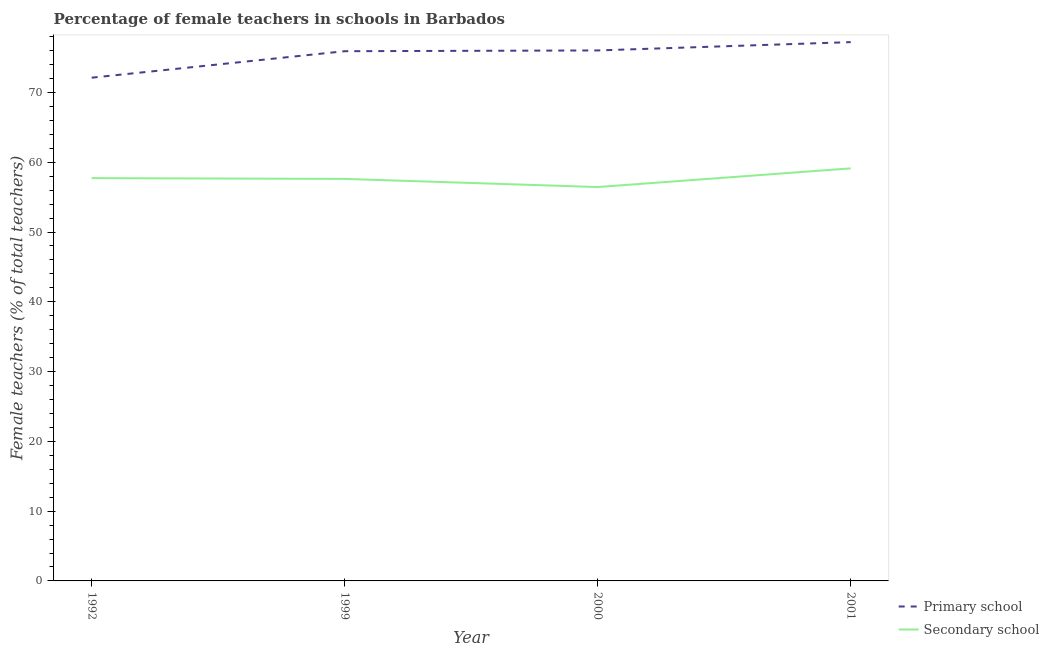How many different coloured lines are there?
Offer a terse response. 2. Does the line corresponding to percentage of female teachers in primary schools intersect with the line corresponding to percentage of female teachers in secondary schools?
Ensure brevity in your answer.  No. What is the percentage of female teachers in secondary schools in 1992?
Make the answer very short. 57.72. Across all years, what is the maximum percentage of female teachers in secondary schools?
Provide a succinct answer. 59.13. Across all years, what is the minimum percentage of female teachers in secondary schools?
Your response must be concise. 56.45. In which year was the percentage of female teachers in secondary schools maximum?
Offer a very short reply. 2001. What is the total percentage of female teachers in secondary schools in the graph?
Your response must be concise. 230.91. What is the difference between the percentage of female teachers in primary schools in 1992 and that in 2000?
Offer a very short reply. -3.9. What is the difference between the percentage of female teachers in secondary schools in 1999 and the percentage of female teachers in primary schools in 2000?
Ensure brevity in your answer.  -18.41. What is the average percentage of female teachers in secondary schools per year?
Your response must be concise. 57.73. In the year 2001, what is the difference between the percentage of female teachers in primary schools and percentage of female teachers in secondary schools?
Your answer should be compact. 18.09. In how many years, is the percentage of female teachers in secondary schools greater than 70 %?
Make the answer very short. 0. What is the ratio of the percentage of female teachers in primary schools in 2000 to that in 2001?
Your answer should be compact. 0.98. Is the difference between the percentage of female teachers in primary schools in 1992 and 1999 greater than the difference between the percentage of female teachers in secondary schools in 1992 and 1999?
Offer a terse response. No. What is the difference between the highest and the second highest percentage of female teachers in secondary schools?
Make the answer very short. 1.4. What is the difference between the highest and the lowest percentage of female teachers in primary schools?
Offer a very short reply. 5.1. Is the sum of the percentage of female teachers in secondary schools in 1992 and 2001 greater than the maximum percentage of female teachers in primary schools across all years?
Your answer should be very brief. Yes. How many lines are there?
Your answer should be very brief. 2. How many years are there in the graph?
Your response must be concise. 4. What is the difference between two consecutive major ticks on the Y-axis?
Keep it short and to the point. 10. Does the graph contain grids?
Keep it short and to the point. No. How many legend labels are there?
Ensure brevity in your answer.  2. What is the title of the graph?
Your response must be concise. Percentage of female teachers in schools in Barbados. What is the label or title of the X-axis?
Your response must be concise. Year. What is the label or title of the Y-axis?
Give a very brief answer. Female teachers (% of total teachers). What is the Female teachers (% of total teachers) of Primary school in 1992?
Provide a succinct answer. 72.12. What is the Female teachers (% of total teachers) of Secondary school in 1992?
Keep it short and to the point. 57.72. What is the Female teachers (% of total teachers) in Primary school in 1999?
Offer a very short reply. 75.91. What is the Female teachers (% of total teachers) of Secondary school in 1999?
Provide a short and direct response. 57.61. What is the Female teachers (% of total teachers) of Primary school in 2000?
Your answer should be compact. 76.02. What is the Female teachers (% of total teachers) of Secondary school in 2000?
Make the answer very short. 56.45. What is the Female teachers (% of total teachers) of Primary school in 2001?
Ensure brevity in your answer.  77.22. What is the Female teachers (% of total teachers) of Secondary school in 2001?
Make the answer very short. 59.13. Across all years, what is the maximum Female teachers (% of total teachers) of Primary school?
Ensure brevity in your answer.  77.22. Across all years, what is the maximum Female teachers (% of total teachers) in Secondary school?
Offer a terse response. 59.13. Across all years, what is the minimum Female teachers (% of total teachers) of Primary school?
Your response must be concise. 72.12. Across all years, what is the minimum Female teachers (% of total teachers) of Secondary school?
Keep it short and to the point. 56.45. What is the total Female teachers (% of total teachers) of Primary school in the graph?
Give a very brief answer. 301.27. What is the total Female teachers (% of total teachers) of Secondary school in the graph?
Your response must be concise. 230.91. What is the difference between the Female teachers (% of total teachers) in Primary school in 1992 and that in 1999?
Offer a very short reply. -3.8. What is the difference between the Female teachers (% of total teachers) of Secondary school in 1992 and that in 1999?
Give a very brief answer. 0.11. What is the difference between the Female teachers (% of total teachers) in Primary school in 1992 and that in 2000?
Ensure brevity in your answer.  -3.9. What is the difference between the Female teachers (% of total teachers) of Secondary school in 1992 and that in 2000?
Give a very brief answer. 1.28. What is the difference between the Female teachers (% of total teachers) of Primary school in 1992 and that in 2001?
Make the answer very short. -5.1. What is the difference between the Female teachers (% of total teachers) in Secondary school in 1992 and that in 2001?
Make the answer very short. -1.4. What is the difference between the Female teachers (% of total teachers) in Primary school in 1999 and that in 2000?
Offer a very short reply. -0.11. What is the difference between the Female teachers (% of total teachers) in Secondary school in 1999 and that in 2000?
Make the answer very short. 1.17. What is the difference between the Female teachers (% of total teachers) in Primary school in 1999 and that in 2001?
Make the answer very short. -1.3. What is the difference between the Female teachers (% of total teachers) of Secondary school in 1999 and that in 2001?
Offer a very short reply. -1.51. What is the difference between the Female teachers (% of total teachers) of Primary school in 2000 and that in 2001?
Offer a very short reply. -1.19. What is the difference between the Female teachers (% of total teachers) in Secondary school in 2000 and that in 2001?
Offer a terse response. -2.68. What is the difference between the Female teachers (% of total teachers) of Primary school in 1992 and the Female teachers (% of total teachers) of Secondary school in 1999?
Your answer should be very brief. 14.51. What is the difference between the Female teachers (% of total teachers) in Primary school in 1992 and the Female teachers (% of total teachers) in Secondary school in 2000?
Keep it short and to the point. 15.67. What is the difference between the Female teachers (% of total teachers) of Primary school in 1992 and the Female teachers (% of total teachers) of Secondary school in 2001?
Keep it short and to the point. 12.99. What is the difference between the Female teachers (% of total teachers) of Primary school in 1999 and the Female teachers (% of total teachers) of Secondary school in 2000?
Your response must be concise. 19.47. What is the difference between the Female teachers (% of total teachers) in Primary school in 1999 and the Female teachers (% of total teachers) in Secondary school in 2001?
Offer a terse response. 16.79. What is the difference between the Female teachers (% of total teachers) in Primary school in 2000 and the Female teachers (% of total teachers) in Secondary school in 2001?
Your answer should be very brief. 16.9. What is the average Female teachers (% of total teachers) in Primary school per year?
Give a very brief answer. 75.32. What is the average Female teachers (% of total teachers) of Secondary school per year?
Keep it short and to the point. 57.73. In the year 1992, what is the difference between the Female teachers (% of total teachers) of Primary school and Female teachers (% of total teachers) of Secondary school?
Ensure brevity in your answer.  14.39. In the year 1999, what is the difference between the Female teachers (% of total teachers) of Primary school and Female teachers (% of total teachers) of Secondary school?
Your response must be concise. 18.3. In the year 2000, what is the difference between the Female teachers (% of total teachers) of Primary school and Female teachers (% of total teachers) of Secondary school?
Make the answer very short. 19.58. In the year 2001, what is the difference between the Female teachers (% of total teachers) in Primary school and Female teachers (% of total teachers) in Secondary school?
Provide a short and direct response. 18.09. What is the ratio of the Female teachers (% of total teachers) of Primary school in 1992 to that in 2000?
Your answer should be very brief. 0.95. What is the ratio of the Female teachers (% of total teachers) of Secondary school in 1992 to that in 2000?
Your answer should be very brief. 1.02. What is the ratio of the Female teachers (% of total teachers) in Primary school in 1992 to that in 2001?
Offer a terse response. 0.93. What is the ratio of the Female teachers (% of total teachers) of Secondary school in 1992 to that in 2001?
Ensure brevity in your answer.  0.98. What is the ratio of the Female teachers (% of total teachers) in Primary school in 1999 to that in 2000?
Make the answer very short. 1. What is the ratio of the Female teachers (% of total teachers) in Secondary school in 1999 to that in 2000?
Offer a terse response. 1.02. What is the ratio of the Female teachers (% of total teachers) in Primary school in 1999 to that in 2001?
Your answer should be very brief. 0.98. What is the ratio of the Female teachers (% of total teachers) in Secondary school in 1999 to that in 2001?
Offer a terse response. 0.97. What is the ratio of the Female teachers (% of total teachers) in Primary school in 2000 to that in 2001?
Your response must be concise. 0.98. What is the ratio of the Female teachers (% of total teachers) of Secondary school in 2000 to that in 2001?
Provide a succinct answer. 0.95. What is the difference between the highest and the second highest Female teachers (% of total teachers) in Primary school?
Keep it short and to the point. 1.19. What is the difference between the highest and the second highest Female teachers (% of total teachers) of Secondary school?
Make the answer very short. 1.4. What is the difference between the highest and the lowest Female teachers (% of total teachers) in Primary school?
Offer a terse response. 5.1. What is the difference between the highest and the lowest Female teachers (% of total teachers) of Secondary school?
Give a very brief answer. 2.68. 